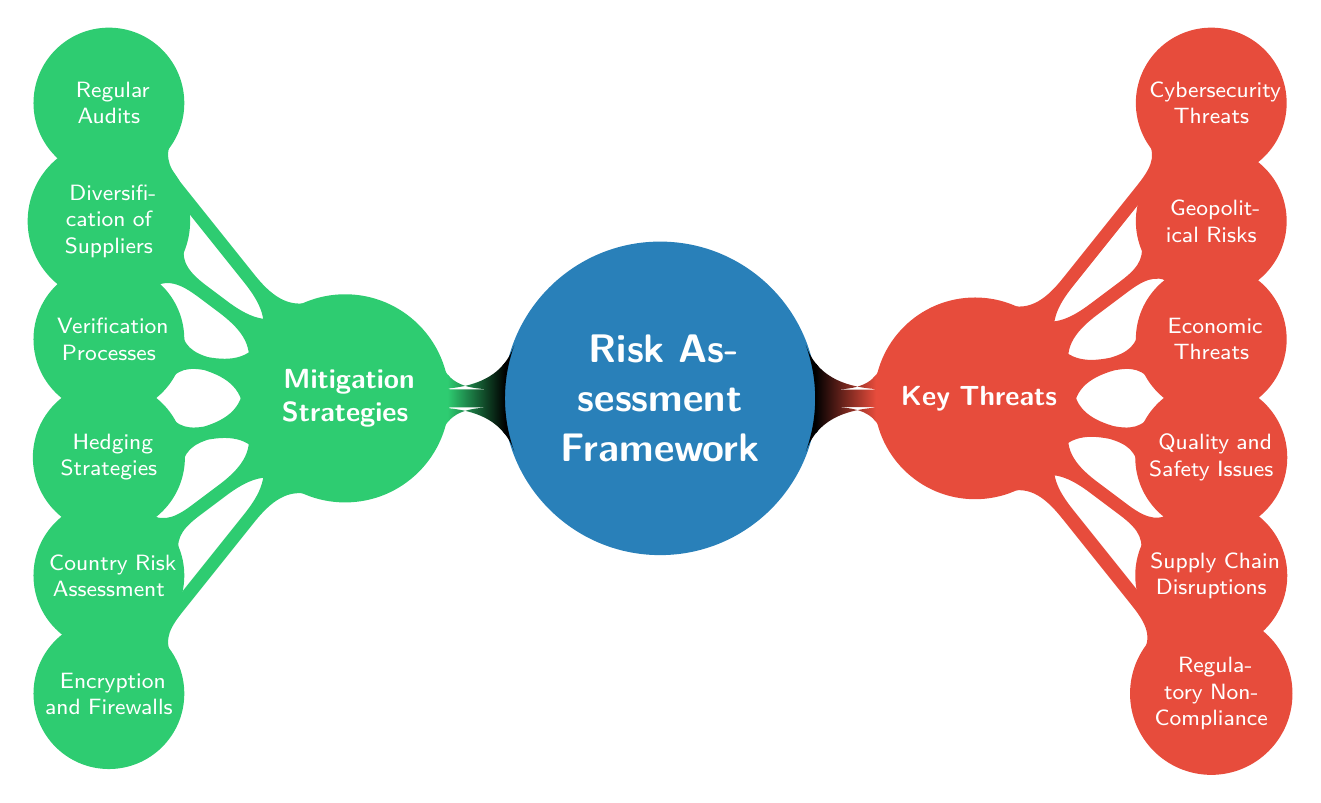What are the two main categories in the risk assessment framework? The diagram clearly shows two main categories stemming from the root concept: "Key Threats" and "Mitigation Strategies." These categories are represented as the primary branches of the mind map.
Answer: Key Threats and Mitigation Strategies How many key threats are listed in the diagram? The mind map indicates a total of six key threats, as evident from the branches labeled under "Key Threats," specifically listed as Regulatory Non-Compliance, Supply Chain Disruptions, Quality and Safety Issues, Economic Threats, Geopolitical Risks, and Cybersecurity Threats.
Answer: Six Which threat is related to counterfeiting? The threat related to counterfeiting is found under "Quality and Safety Issues," which specifically mentions "Counterfeit Goods" as one of its sub-elements, directly connecting it to the concern regarding product authenticity and safety.
Answer: Counterfeit Goods What mitigation strategy corresponds to ensuring compliance? The mitigation strategy that corresponds to ensuring compliance is "Regular Audits," as this is part of the sub-elements under "Regulatory Non-Compliance." Regular audits are essential for verifying adherence to regulatory requirements.
Answer: Regular Audits Which economic threat relates to trade policies? The economic threat that relates to trade policies is "Changes in Trade Policies," as indicated in the relevant sub-elements listed under "Economic Threats." This threat is significant because it can affect the flow and cost of imported goods.
Answer: Changes in Trade Policies What relationship exists between "Supplier Bankruptcy" and "Diversification of Suppliers"? "Supplier Bankruptcy," listed as a key threat, emphasizes the risk of relying on a single supplier, whereas "Diversification of Suppliers" is a mitigation strategy aimed at reducing the risk associated with supplier bankruptcy. Thus, the relationship is that diversification acts as a countermeasure to the threat of bankruptcy.
Answer: Diversification of Suppliers reduces the risk of Supplier Bankruptcy How many sub-elements are under "Cybersecurity Threats"? There are three sub-elements listed under "Cybersecurity Threats": "Data Breaches," "Supply Chain Attacks," and "Malware." Each of these represents different aspects of cybersecurity risks that imported goods might face.
Answer: Three Which key threat is the most complex in terms of sub-elements management? "Supply Chain Disruptions" could be considered the most complex key threat due to involving three distinct sub-elements: "Natural Disasters," "Transportation Delays," and "Supplier Bankruptcy." Managing multiple risks in the supply chain often requires careful planning and strategies to minimize disruption.
Answer: Supply Chain Disruptions 